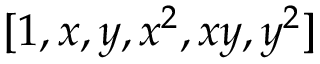<formula> <loc_0><loc_0><loc_500><loc_500>[ 1 , x , y , x ^ { 2 } , x y , y ^ { 2 } ]</formula> 